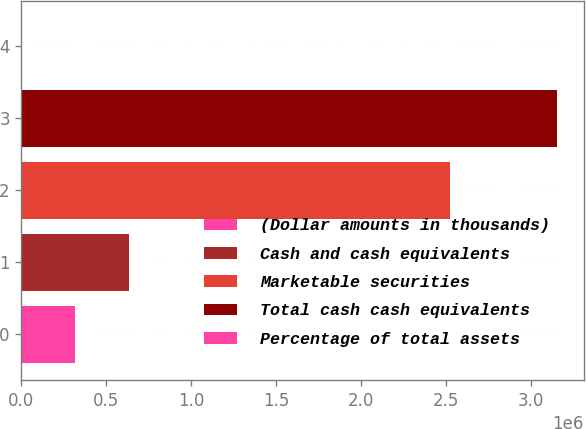Convert chart to OTSL. <chart><loc_0><loc_0><loc_500><loc_500><bar_chart><fcel>(Dollar amounts in thousands)<fcel>Cash and cash equivalents<fcel>Marketable securities<fcel>Total cash cash equivalents<fcel>Percentage of total assets<nl><fcel>315315<fcel>630861<fcel>2.52178e+06<fcel>3.15264e+06<fcel>57<nl></chart> 